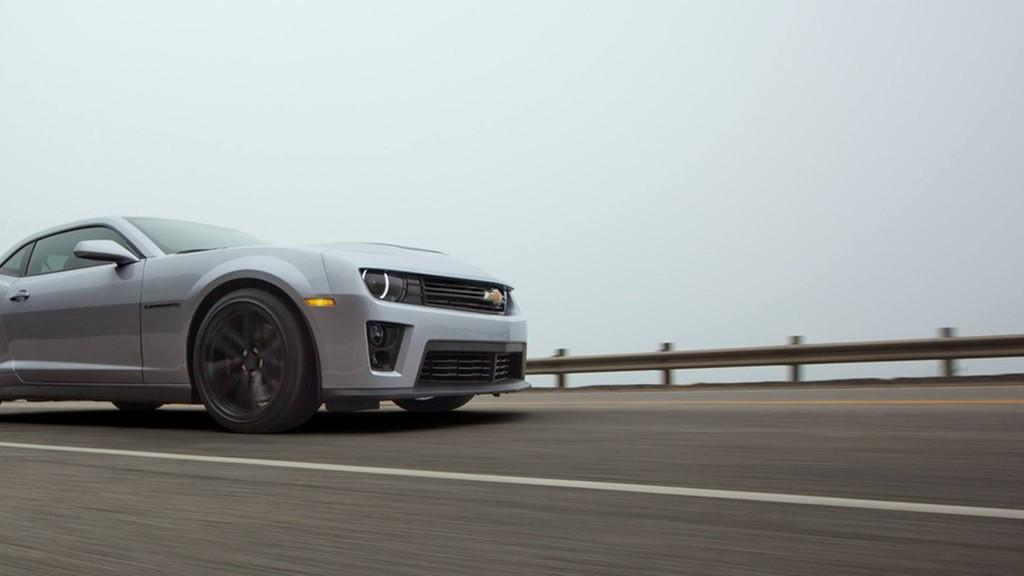What is the main subject of the image? The main subject of the image is a car. Where is the car located in the image? The car is on the road in the image. What can be seen in the background of the image? The sky is visible in the background of the image. Is there a station visible in the image? There is no station present in the image; it features a car on the road with the sky visible in the background. Can you see a volcano erupting in the image? There is no volcano present in the image; it features a car on the road with the sky visible in the background. 